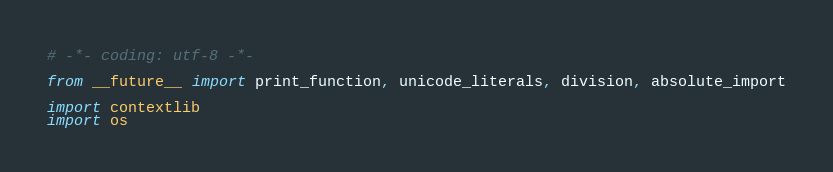Convert code to text. <code><loc_0><loc_0><loc_500><loc_500><_Python_># -*- coding: utf-8 -*-

from __future__ import print_function, unicode_literals, division, absolute_import

import contextlib
import os</code> 